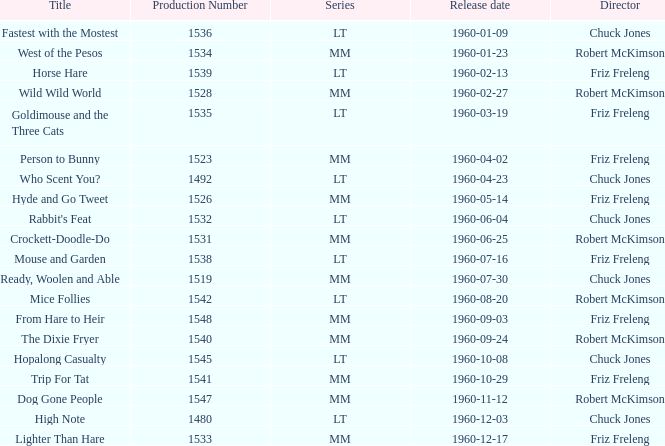What is the Series number of the episode with a production number of 1547? MM. 